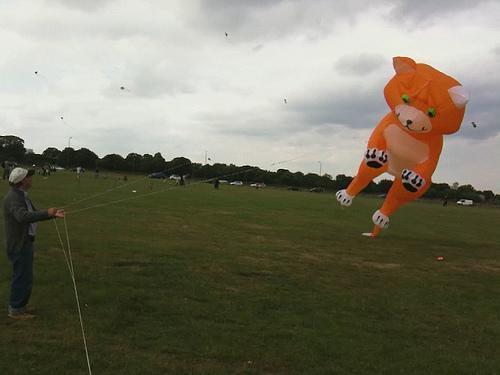How many kites does it seem the man is flying?
Give a very brief answer. 3. 